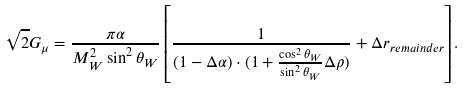Convert formula to latex. <formula><loc_0><loc_0><loc_500><loc_500>\sqrt { 2 } G _ { \mu } = \frac { \pi \alpha } { M _ { W } ^ { 2 } \sin ^ { 2 } \theta _ { W } } \left [ \frac { 1 } { ( 1 - \Delta \alpha ) \cdot ( 1 + \frac { \cos ^ { 2 } \theta _ { W } } { \sin ^ { 2 } \theta _ { W } } \Delta \rho ) } + \Delta r _ { r e m a i n d e r } \right ] .</formula> 